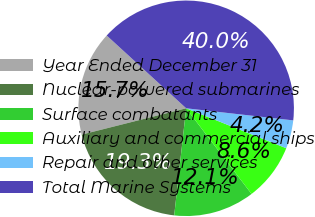<chart> <loc_0><loc_0><loc_500><loc_500><pie_chart><fcel>Year Ended December 31<fcel>Nuclear-powered submarines<fcel>Surface combatants<fcel>Auxiliary and commercial ships<fcel>Repair and other services<fcel>Total Marine Systems<nl><fcel>15.73%<fcel>19.3%<fcel>12.15%<fcel>8.58%<fcel>4.25%<fcel>39.99%<nl></chart> 